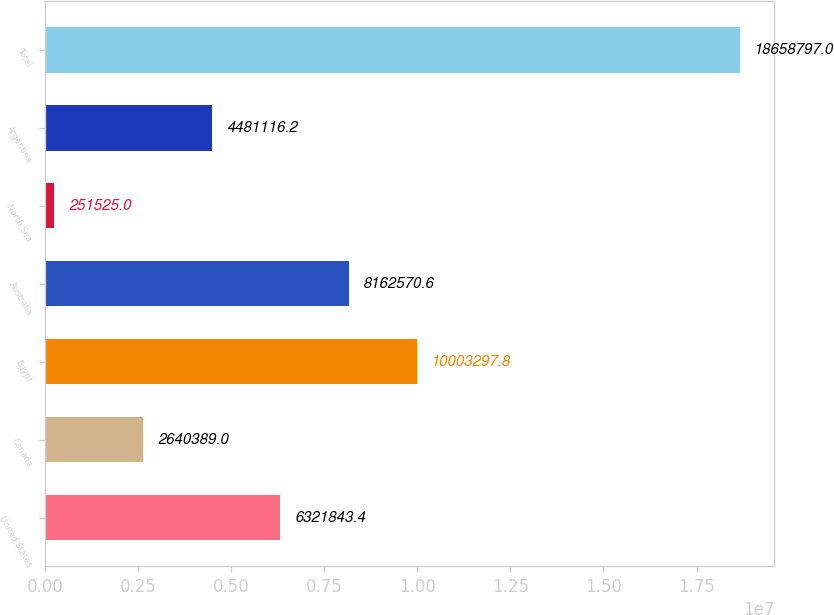Convert chart. <chart><loc_0><loc_0><loc_500><loc_500><bar_chart><fcel>United States<fcel>Canada<fcel>Egypt<fcel>Australia<fcel>North Sea<fcel>Argentina<fcel>Total<nl><fcel>6.32184e+06<fcel>2.64039e+06<fcel>1.00033e+07<fcel>8.16257e+06<fcel>251525<fcel>4.48112e+06<fcel>1.86588e+07<nl></chart> 